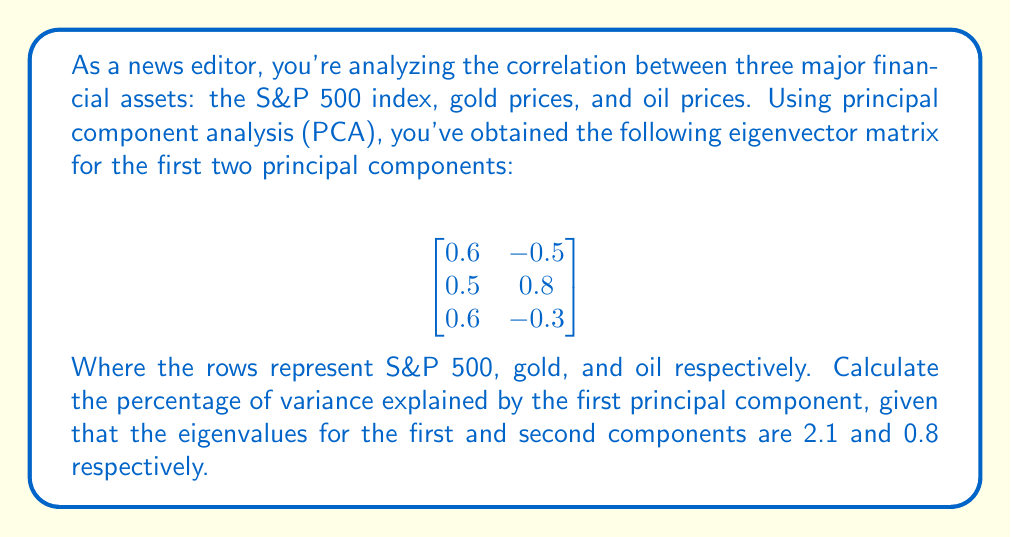Show me your answer to this math problem. To solve this problem, we'll follow these steps:

1) In PCA, the percentage of variance explained by each principal component is proportional to its eigenvalue.

2) The total variance is the sum of all eigenvalues. Here, we have:
   Total variance = $2.1 + 0.8 = 2.9$

3) The proportion of variance explained by the first principal component is:
   $$\frac{\text{Eigenvalue of first component}}{\text{Total variance}} = \frac{2.1}{2.9}$$

4) To convert to a percentage, we multiply by 100:
   $$\frac{2.1}{2.9} * 100 = 72.41\%$$

5) Round to two decimal places for the final answer.

This result indicates that the first principal component accounts for about 72.41% of the total variance in the dataset, suggesting a strong correlation structure among the three financial assets.
Answer: 72.41% 